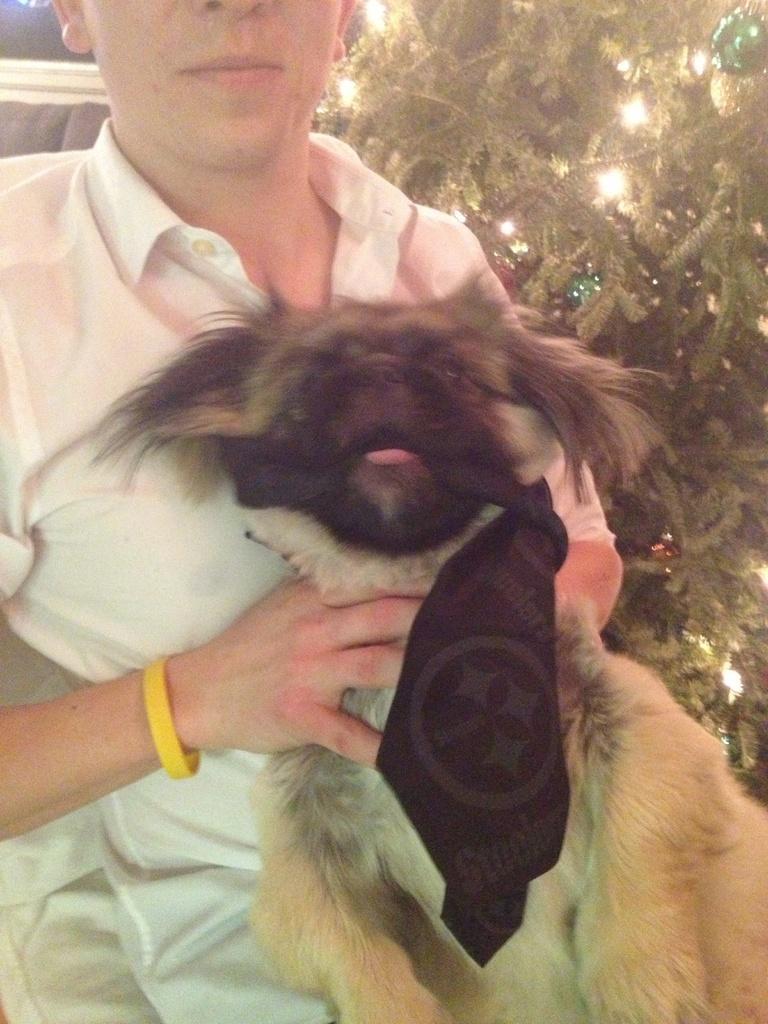In one or two sentences, can you explain what this image depicts? In this picture we can see a person holding a dog, in the background we can see a plant. 